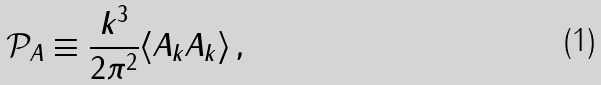Convert formula to latex. <formula><loc_0><loc_0><loc_500><loc_500>\mathcal { P } _ { A } \equiv \frac { k ^ { 3 } } { 2 \pi ^ { 2 } } \langle A _ { k } A _ { k } \rangle \, ,</formula> 